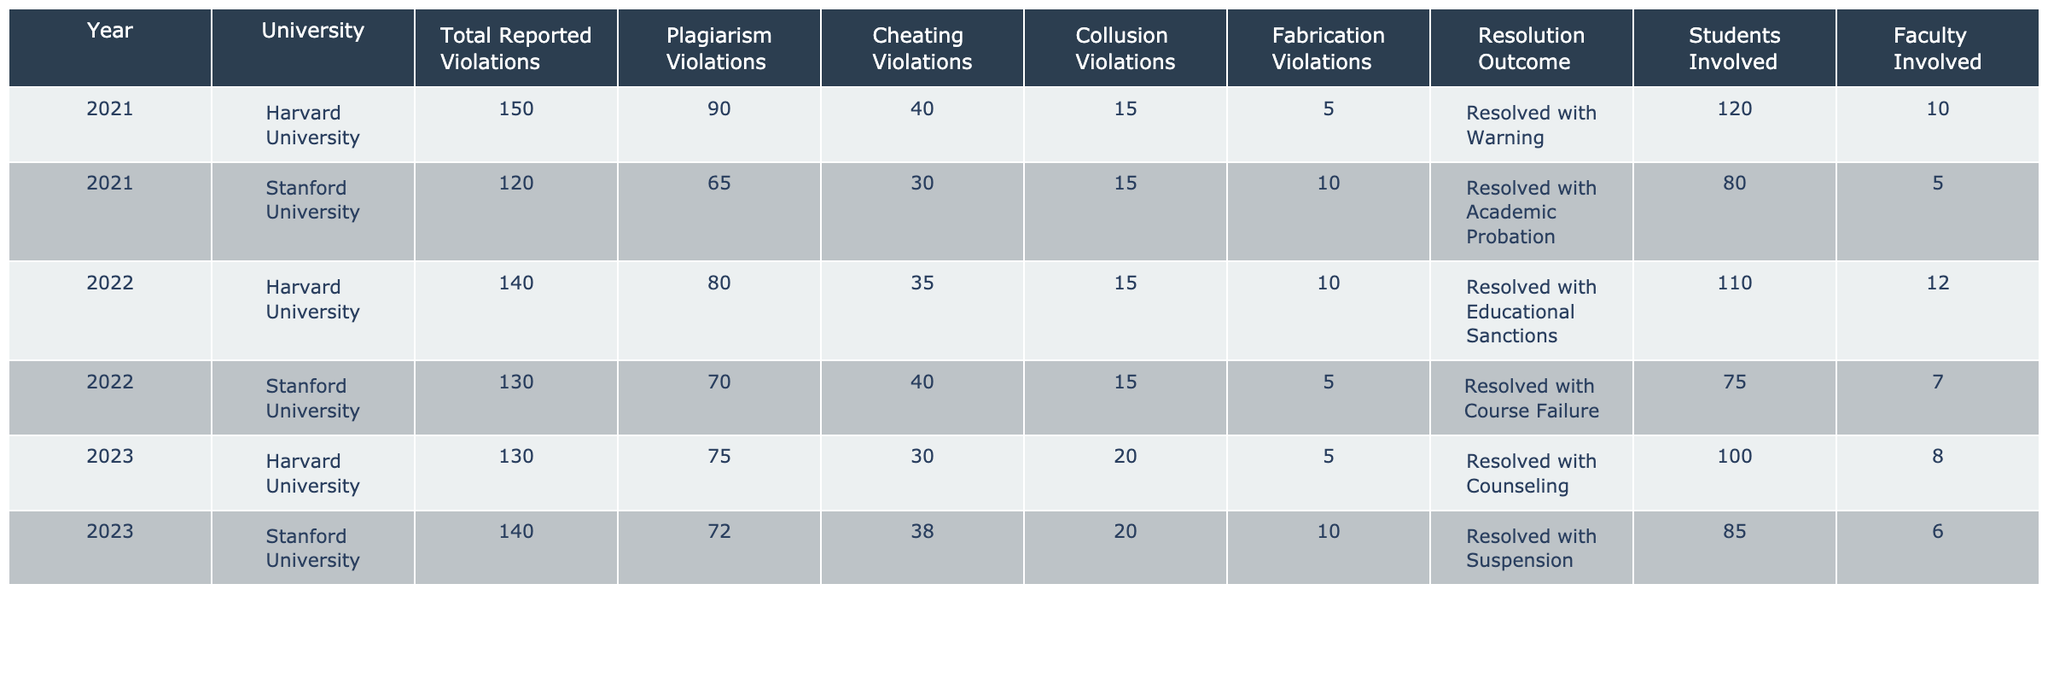What was the total number of reported violations at Stanford University in 2022? The table shows that there were 130 total reported violations at Stanford University in 2022.
Answer: 130 How many students were involved in academic integrity violations at Harvard University in 2021? According to the table, 120 students were involved in violations at Harvard University in 2021.
Answer: 120 Which university had the highest number of plagiarism violations in 2023? The table indicates that Harvard University had 75 plagiarism violations, while Stanford had 72. Hence, Harvard University had the highest number of plagiarism violations in 2023.
Answer: Harvard University What is the difference in total reported violations between Stanford University in 2022 and 2023? The total reported violations at Stanford University were 130 in 2022 and 140 in 2023. The difference is 140 - 130 = 10.
Answer: 10 What was the resolution outcome with the highest number of violations at Harvard University in 2022? The table shows the resolution outcome for Harvard University in 2022 was "Resolved with Educational Sanctions," with 10 violations resulting in that outcome. However, since it does not represent the highest number of violations, it’s essential to look for other resolutions; the highest in the same year is also "Resolved with Educational Sanctions" since no other outcome had more than 10.
Answer: Resolved with Educational Sanctions Which year had the highest total reported violations across both universities, and what was that total? Summing the total reported violations per year: 2021: 150 + 120 = 270, 2022: 140 + 130 = 270, 2023: 130 + 140 = 270. All three years have the same totals.
Answer: 270 Did Stanford University have more cheating violations than Harvard University in 2021? The table indicates that Stanford University had 30 cheating violations while Harvard University had 40. Thus, Stanford did not have more cheating violations.
Answer: No In 2023, what percentage of total reported violations at Harvard University were related to fabrication? Harvard had 130 total reported violations and 5 were related to fabrication. The percentage is calculated as (5/130) * 100 = 3.85%.
Answer: 3.85% What is the average number of students involved in academic integrity violations across both universities for 2022? The total number of students involved in 2022 was 110 (Harvard) + 75 (Stanford) = 185. There are 2 universities, so the average is 185/2 = 92.5.
Answer: 92.5 What was the trend in cheating violations from 2021 to 2023 at both universities combined? In 2021, there were 40 + 30 = 70 cheating violations; in 2022, there were 35 + 40 = 75; in 2023, it decreased to 30 + 38 = 68. The trend indicates a peak in 2022 followed by a decrease in 2023.
Answer: Increased from 2021 to 2022, then decreased in 2023 